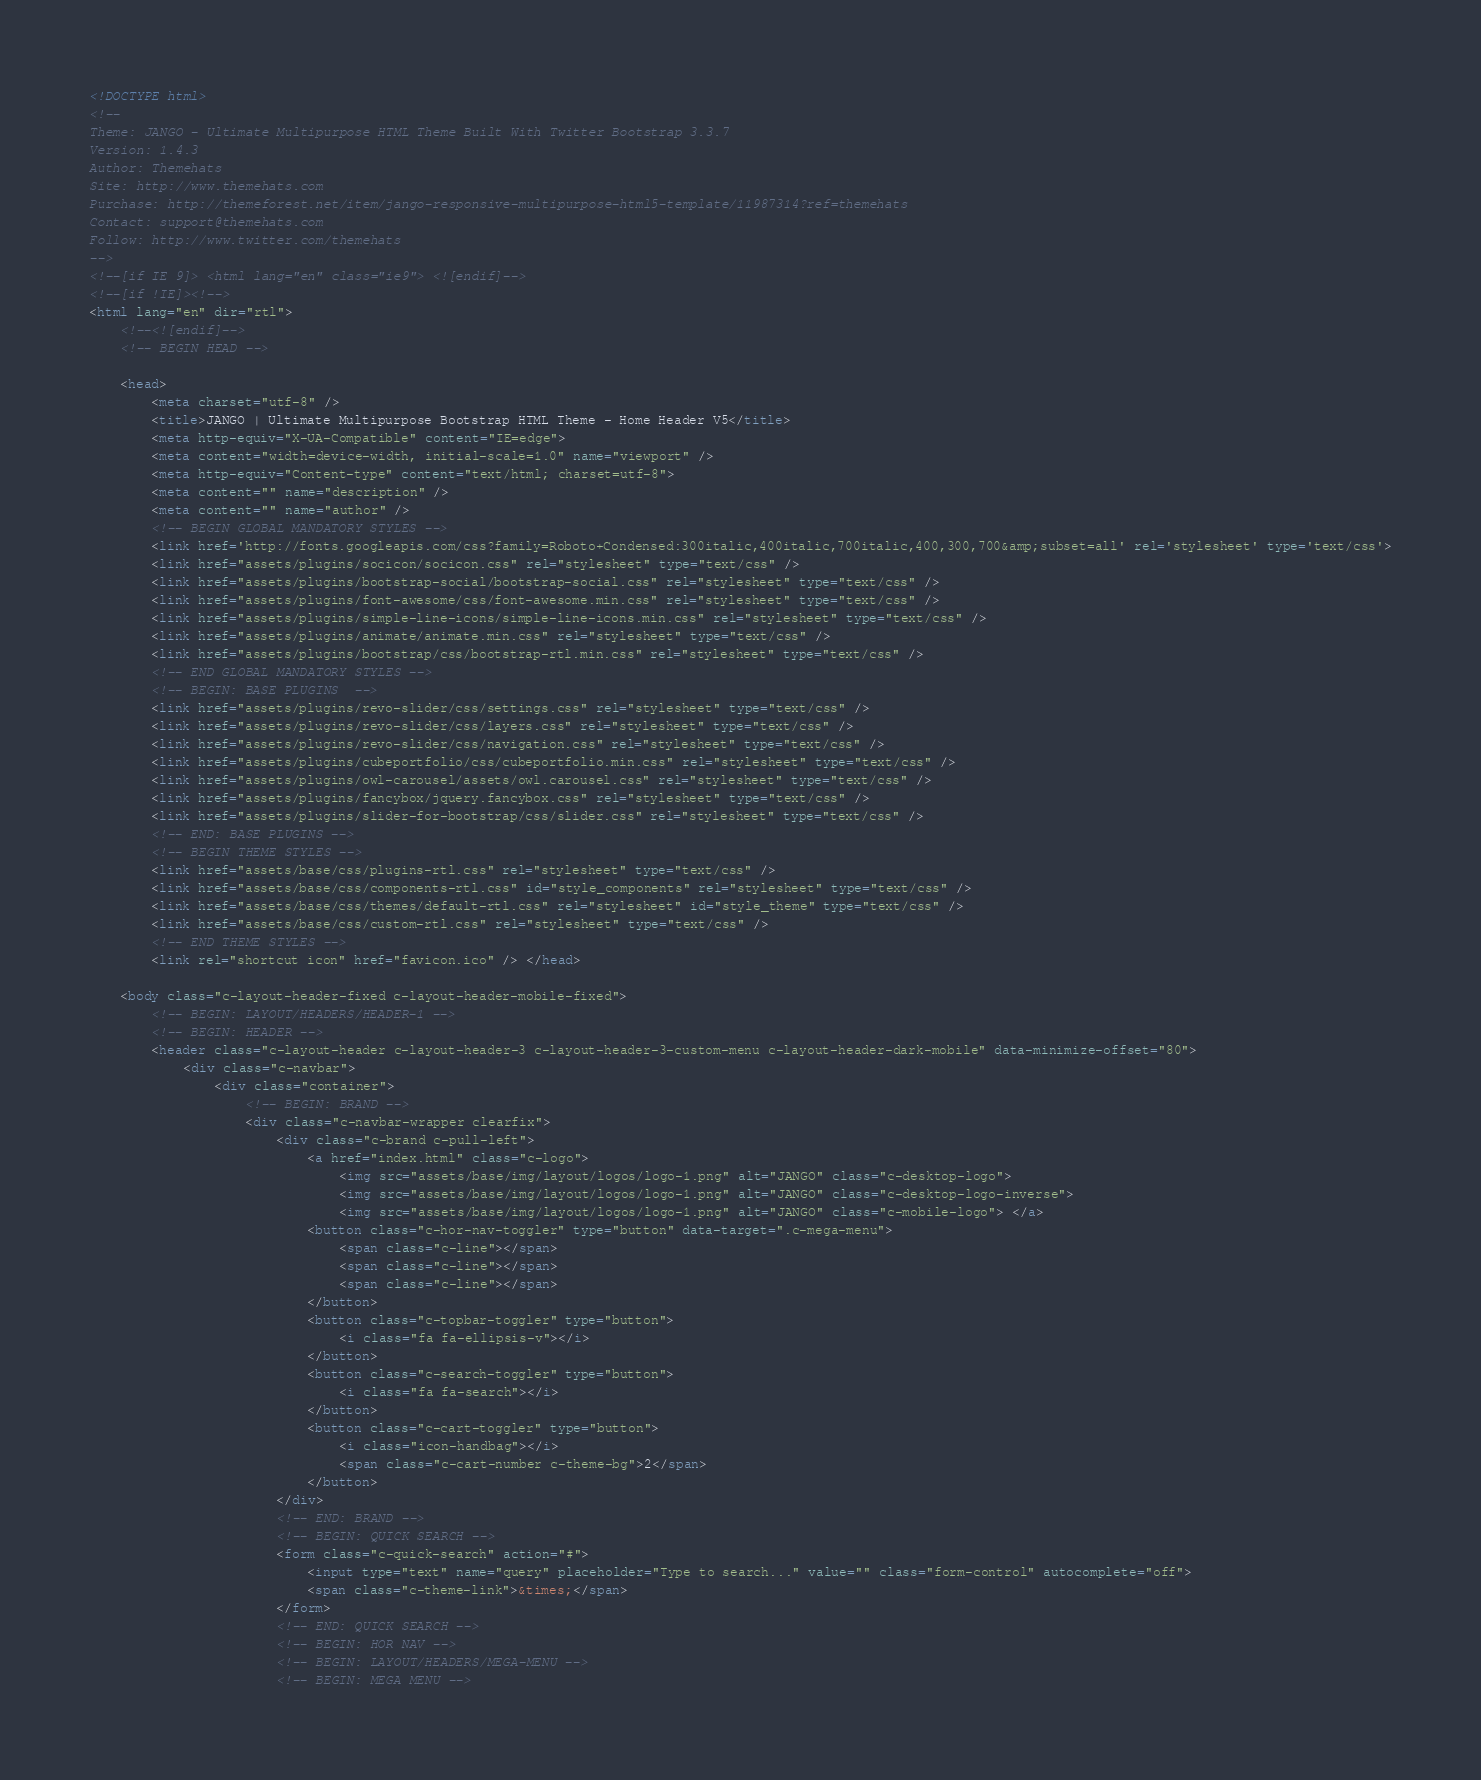Convert code to text. <code><loc_0><loc_0><loc_500><loc_500><_HTML_><!DOCTYPE html>
<!-- 
Theme: JANGO - Ultimate Multipurpose HTML Theme Built With Twitter Bootstrap 3.3.7
Version: 1.4.3
Author: Themehats
Site: http://www.themehats.com
Purchase: http://themeforest.net/item/jango-responsive-multipurpose-html5-template/11987314?ref=themehats
Contact: support@themehats.com
Follow: http://www.twitter.com/themehats
-->
<!--[if IE 9]> <html lang="en" class="ie9"> <![endif]-->
<!--[if !IE]><!-->
<html lang="en" dir="rtl">
    <!--<![endif]-->
    <!-- BEGIN HEAD -->

    <head>
        <meta charset="utf-8" />
        <title>JANGO | Ultimate Multipurpose Bootstrap HTML Theme - Home Header V5</title>
        <meta http-equiv="X-UA-Compatible" content="IE=edge">
        <meta content="width=device-width, initial-scale=1.0" name="viewport" />
        <meta http-equiv="Content-type" content="text/html; charset=utf-8">
        <meta content="" name="description" />
        <meta content="" name="author" />
        <!-- BEGIN GLOBAL MANDATORY STYLES -->
        <link href='http://fonts.googleapis.com/css?family=Roboto+Condensed:300italic,400italic,700italic,400,300,700&amp;subset=all' rel='stylesheet' type='text/css'>
        <link href="assets/plugins/socicon/socicon.css" rel="stylesheet" type="text/css" />
        <link href="assets/plugins/bootstrap-social/bootstrap-social.css" rel="stylesheet" type="text/css" />
        <link href="assets/plugins/font-awesome/css/font-awesome.min.css" rel="stylesheet" type="text/css" />
        <link href="assets/plugins/simple-line-icons/simple-line-icons.min.css" rel="stylesheet" type="text/css" />
        <link href="assets/plugins/animate/animate.min.css" rel="stylesheet" type="text/css" />
        <link href="assets/plugins/bootstrap/css/bootstrap-rtl.min.css" rel="stylesheet" type="text/css" />
        <!-- END GLOBAL MANDATORY STYLES -->
        <!-- BEGIN: BASE PLUGINS  -->
        <link href="assets/plugins/revo-slider/css/settings.css" rel="stylesheet" type="text/css" />
        <link href="assets/plugins/revo-slider/css/layers.css" rel="stylesheet" type="text/css" />
        <link href="assets/plugins/revo-slider/css/navigation.css" rel="stylesheet" type="text/css" />
        <link href="assets/plugins/cubeportfolio/css/cubeportfolio.min.css" rel="stylesheet" type="text/css" />
        <link href="assets/plugins/owl-carousel/assets/owl.carousel.css" rel="stylesheet" type="text/css" />
        <link href="assets/plugins/fancybox/jquery.fancybox.css" rel="stylesheet" type="text/css" />
        <link href="assets/plugins/slider-for-bootstrap/css/slider.css" rel="stylesheet" type="text/css" />
        <!-- END: BASE PLUGINS -->
        <!-- BEGIN THEME STYLES -->
        <link href="assets/base/css/plugins-rtl.css" rel="stylesheet" type="text/css" />
        <link href="assets/base/css/components-rtl.css" id="style_components" rel="stylesheet" type="text/css" />
        <link href="assets/base/css/themes/default-rtl.css" rel="stylesheet" id="style_theme" type="text/css" />
        <link href="assets/base/css/custom-rtl.css" rel="stylesheet" type="text/css" />
        <!-- END THEME STYLES -->
        <link rel="shortcut icon" href="favicon.ico" /> </head>

    <body class="c-layout-header-fixed c-layout-header-mobile-fixed">
        <!-- BEGIN: LAYOUT/HEADERS/HEADER-1 -->
        <!-- BEGIN: HEADER -->
        <header class="c-layout-header c-layout-header-3 c-layout-header-3-custom-menu c-layout-header-dark-mobile" data-minimize-offset="80">
            <div class="c-navbar">
                <div class="container">
                    <!-- BEGIN: BRAND -->
                    <div class="c-navbar-wrapper clearfix">
                        <div class="c-brand c-pull-left">
                            <a href="index.html" class="c-logo">
                                <img src="assets/base/img/layout/logos/logo-1.png" alt="JANGO" class="c-desktop-logo">
                                <img src="assets/base/img/layout/logos/logo-1.png" alt="JANGO" class="c-desktop-logo-inverse">
                                <img src="assets/base/img/layout/logos/logo-1.png" alt="JANGO" class="c-mobile-logo"> </a>
                            <button class="c-hor-nav-toggler" type="button" data-target=".c-mega-menu">
                                <span class="c-line"></span>
                                <span class="c-line"></span>
                                <span class="c-line"></span>
                            </button>
                            <button class="c-topbar-toggler" type="button">
                                <i class="fa fa-ellipsis-v"></i>
                            </button>
                            <button class="c-search-toggler" type="button">
                                <i class="fa fa-search"></i>
                            </button>
                            <button class="c-cart-toggler" type="button">
                                <i class="icon-handbag"></i>
                                <span class="c-cart-number c-theme-bg">2</span>
                            </button>
                        </div>
                        <!-- END: BRAND -->
                        <!-- BEGIN: QUICK SEARCH -->
                        <form class="c-quick-search" action="#">
                            <input type="text" name="query" placeholder="Type to search..." value="" class="form-control" autocomplete="off">
                            <span class="c-theme-link">&times;</span>
                        </form>
                        <!-- END: QUICK SEARCH -->
                        <!-- BEGIN: HOR NAV -->
                        <!-- BEGIN: LAYOUT/HEADERS/MEGA-MENU -->
                        <!-- BEGIN: MEGA MENU --></code> 